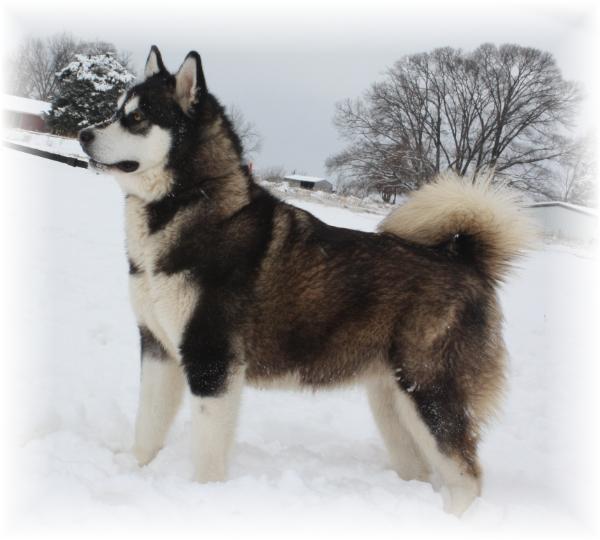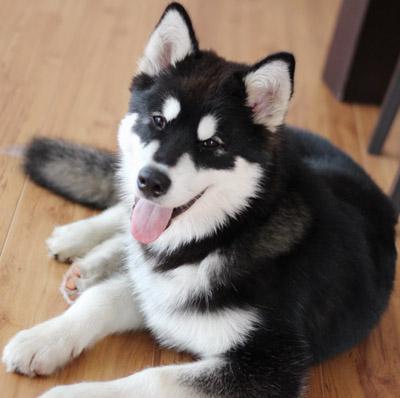The first image is the image on the left, the second image is the image on the right. Considering the images on both sides, is "The left image has exactly one dog with it's mouth closed, the right image has exactly one dog with it's tongue out." valid? Answer yes or no. Yes. 